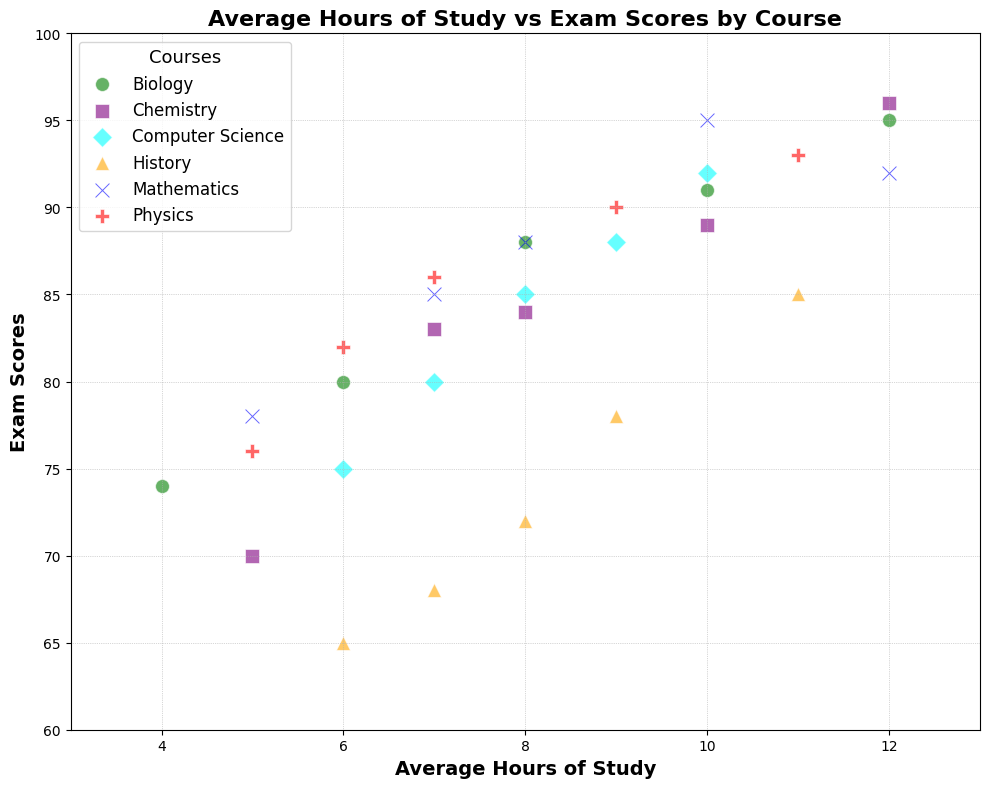What's the course with the highest exam score for a student who studied 10 hours on average? The plot shows that for students who studied 10 hours on average, Mathematics has the highest exam score of 95.
Answer: Mathematics Which course has the widest range of exam scores? To identify the course with the widest range of exam scores, observe the extremes of each course's data points. For Biology, the scores range from 74 to 95, which gives a range of 21, the largest among the courses.
Answer: Biology Is there a course where higher study hours do not clearly correspond to higher exam scores? Observing the trend lines among the courses, History shows a somewhat inconsistent relationship between study hours and exam scores, e.g., jumps between 6 hours of study with a score of 65 and 11 hours of study with a score of 85.
Answer: History Compare the highest exam scores between Physics and Chemistry. Which course has a higher score? The highest exam score in Physics is 93, and the highest in Chemistry is 96. Chemistry has a higher exam score.
Answer: Chemistry What is the average exam score of students who study 9 hours across all courses? To find the average score for 9 study hours, note the data points: Physics (90), History (78), Computer Science (88). Their average is (90 + 78 + 88) / 3 = 85.33.
Answer: 85.33 Which course has the fewest outliers in terms of study hours versus exam scores? Examine each course's spread. The points for Mathematics are closer to each other without much deviation, indicating fewer outliers.
Answer: Mathematics What is the relationship between study hours and exam scores in Biology? Observing Biology's data points, higher study hours generally correspond to higher exam scores, e.g., 4 hours, 74 score; 12 hours, 95 score, indicating a positive trend.
Answer: Positive correlation Compare the minimum exam scores between History and Biology. Which has a lower score? History's minimum exam score is 65, whereas Biology's minimum is 74. Therefore, History has a lower minimum exam score.
Answer: History How does the study time distribution differ between Computer Science and Mathematics? For Computer Science, study times range from 6 to 10 hours, while Mathematics ranges between 5 to 12 hours, suggesting Mathematics has a broader distribution of study times.
Answer: Mathematics 